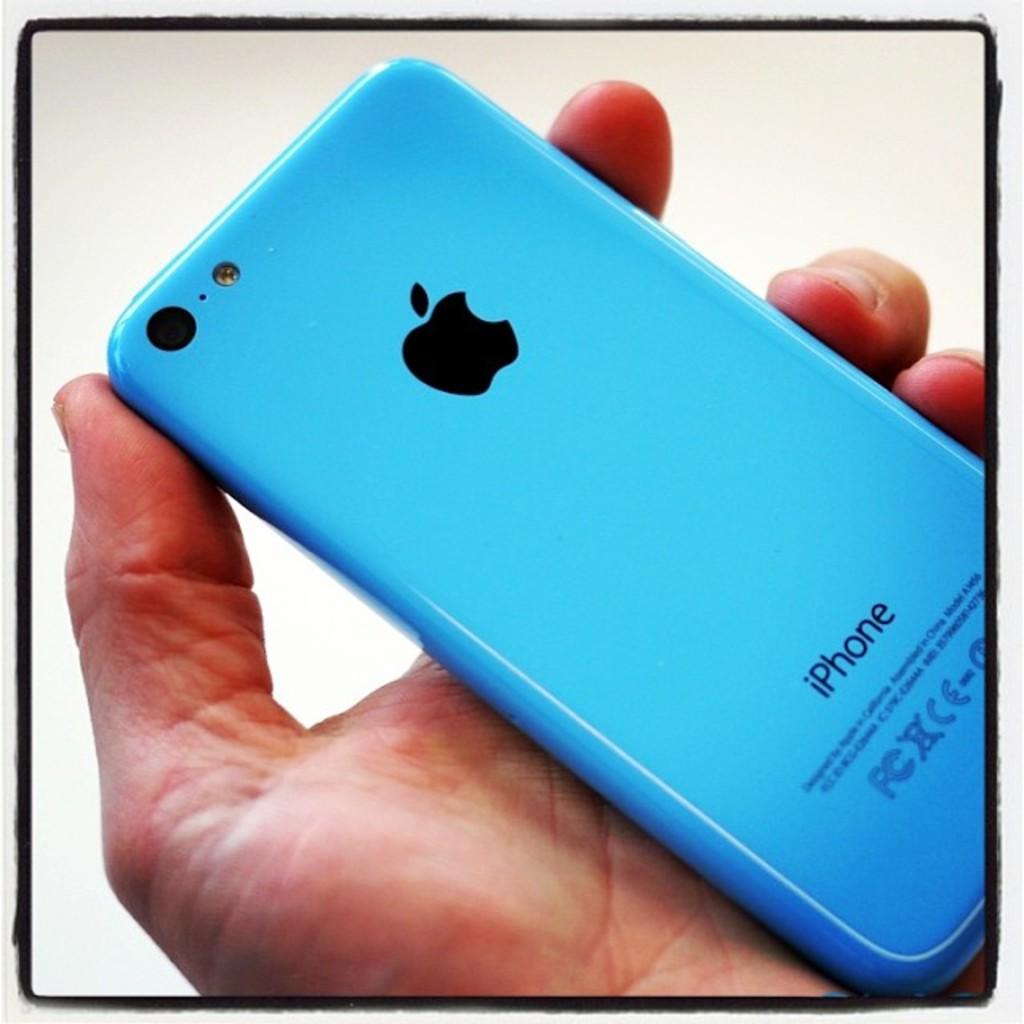What type of iphone is this?
Provide a short and direct response. Unanswerable. 